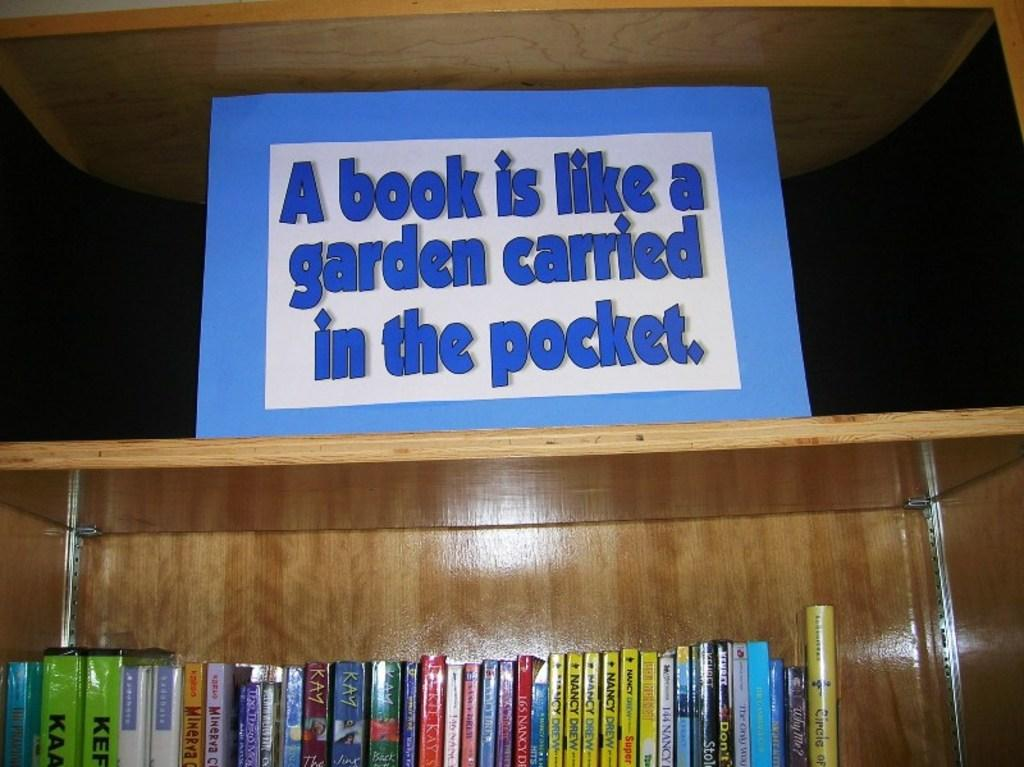<image>
Offer a succinct explanation of the picture presented. A sign above a bookshelf compares a book to a garden carried in a pocket. 